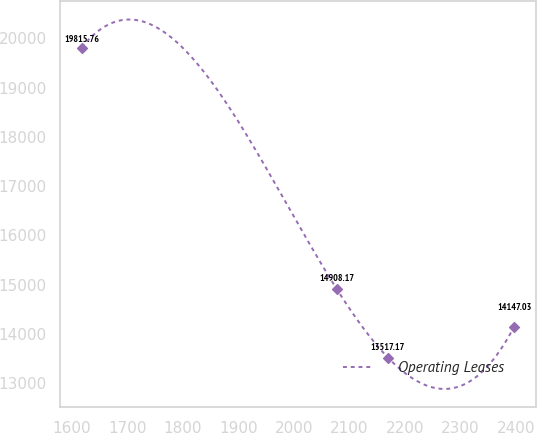<chart> <loc_0><loc_0><loc_500><loc_500><line_chart><ecel><fcel>Operating Leases<nl><fcel>1617.05<fcel>19815.8<nl><fcel>2077.26<fcel>14908.2<nl><fcel>2169.42<fcel>13517.2<nl><fcel>2397.26<fcel>14147<nl></chart> 